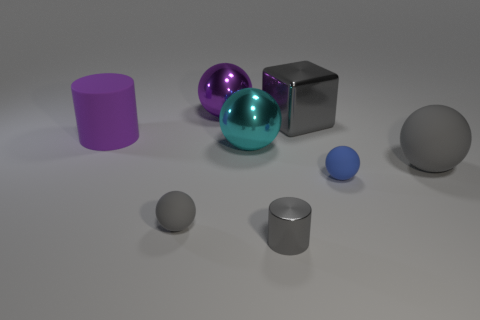Does the large shiny cube have the same color as the small metallic cylinder?
Offer a terse response. Yes. The cyan metallic sphere is what size?
Your answer should be very brief. Large. What number of other things are there of the same color as the small metal cylinder?
Your answer should be compact. 3. Is the sphere that is in front of the tiny blue rubber thing made of the same material as the gray cube?
Your answer should be compact. No. Is the number of gray rubber balls that are to the right of the blue matte ball greater than the number of blue rubber things that are on the left side of the small gray rubber ball?
Keep it short and to the point. Yes. What number of things are either gray spheres that are on the left side of the large cyan sphere or small gray rubber things?
Provide a short and direct response. 1. There is a large gray object that is the same material as the cyan thing; what is its shape?
Give a very brief answer. Cube. Is there any other thing that is the same shape as the large gray metal object?
Provide a succinct answer. No. The object that is both behind the purple matte cylinder and right of the big purple sphere is what color?
Ensure brevity in your answer.  Gray. What number of cubes are either matte objects or gray metal things?
Your answer should be compact. 1. 